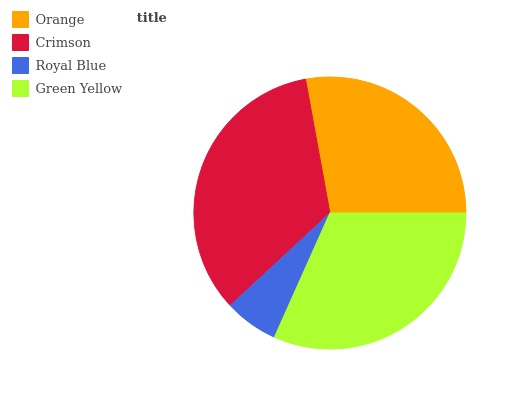Is Royal Blue the minimum?
Answer yes or no. Yes. Is Crimson the maximum?
Answer yes or no. Yes. Is Crimson the minimum?
Answer yes or no. No. Is Royal Blue the maximum?
Answer yes or no. No. Is Crimson greater than Royal Blue?
Answer yes or no. Yes. Is Royal Blue less than Crimson?
Answer yes or no. Yes. Is Royal Blue greater than Crimson?
Answer yes or no. No. Is Crimson less than Royal Blue?
Answer yes or no. No. Is Green Yellow the high median?
Answer yes or no. Yes. Is Orange the low median?
Answer yes or no. Yes. Is Crimson the high median?
Answer yes or no. No. Is Royal Blue the low median?
Answer yes or no. No. 